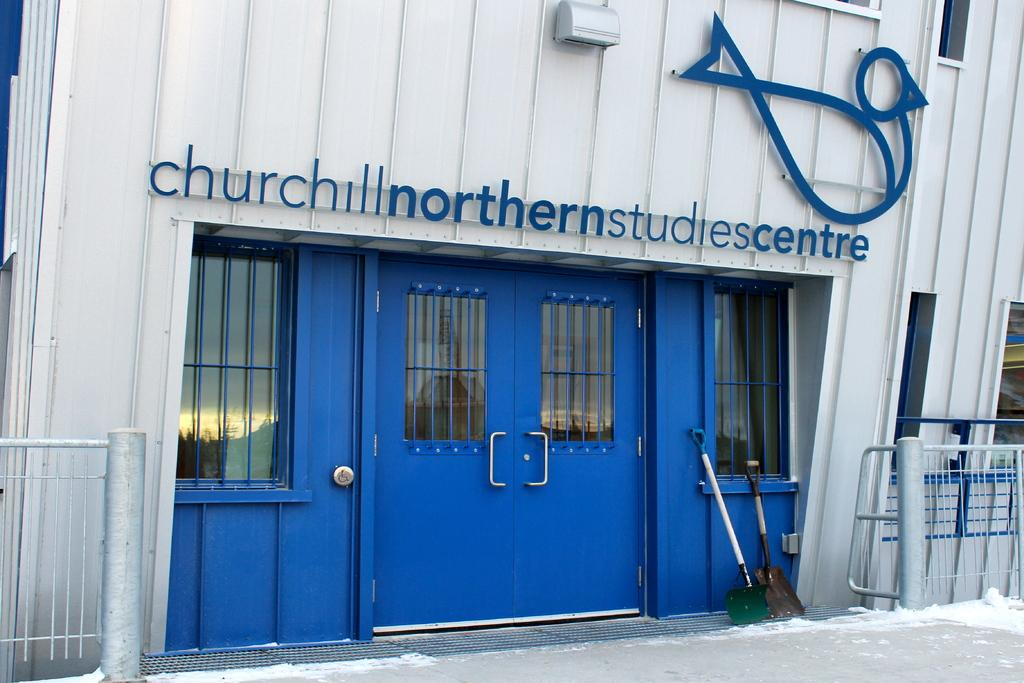<image>
Create a compact narrative representing the image presented. A blue door has a sign for a study centre above it. 